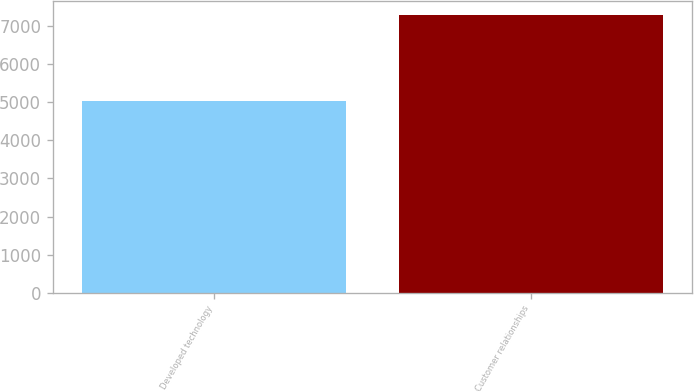Convert chart. <chart><loc_0><loc_0><loc_500><loc_500><bar_chart><fcel>Developed technology<fcel>Customer relationships<nl><fcel>5025<fcel>7292<nl></chart> 